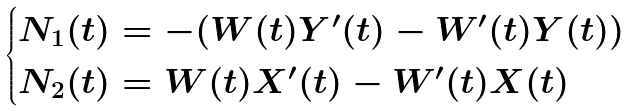<formula> <loc_0><loc_0><loc_500><loc_500>\begin{cases} N _ { 1 } ( t ) = - ( W ( t ) Y ^ { \prime } ( t ) - W ^ { \prime } ( t ) Y ( t ) ) \\ N _ { 2 } ( t ) = W ( t ) X ^ { \prime } ( t ) - W ^ { \prime } ( t ) X ( t ) \end{cases}</formula> 